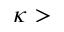<formula> <loc_0><loc_0><loc_500><loc_500>\kappa ></formula> 